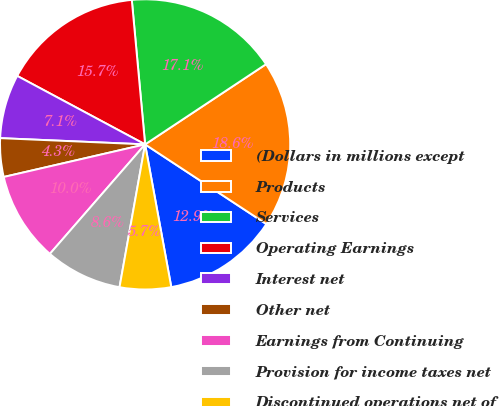Convert chart. <chart><loc_0><loc_0><loc_500><loc_500><pie_chart><fcel>(Dollars in millions except<fcel>Products<fcel>Services<fcel>Operating Earnings<fcel>Interest net<fcel>Other net<fcel>Earnings from Continuing<fcel>Provision for income taxes net<fcel>Discontinued operations net of<nl><fcel>12.86%<fcel>18.57%<fcel>17.14%<fcel>15.71%<fcel>7.14%<fcel>4.29%<fcel>10.0%<fcel>8.57%<fcel>5.71%<nl></chart> 